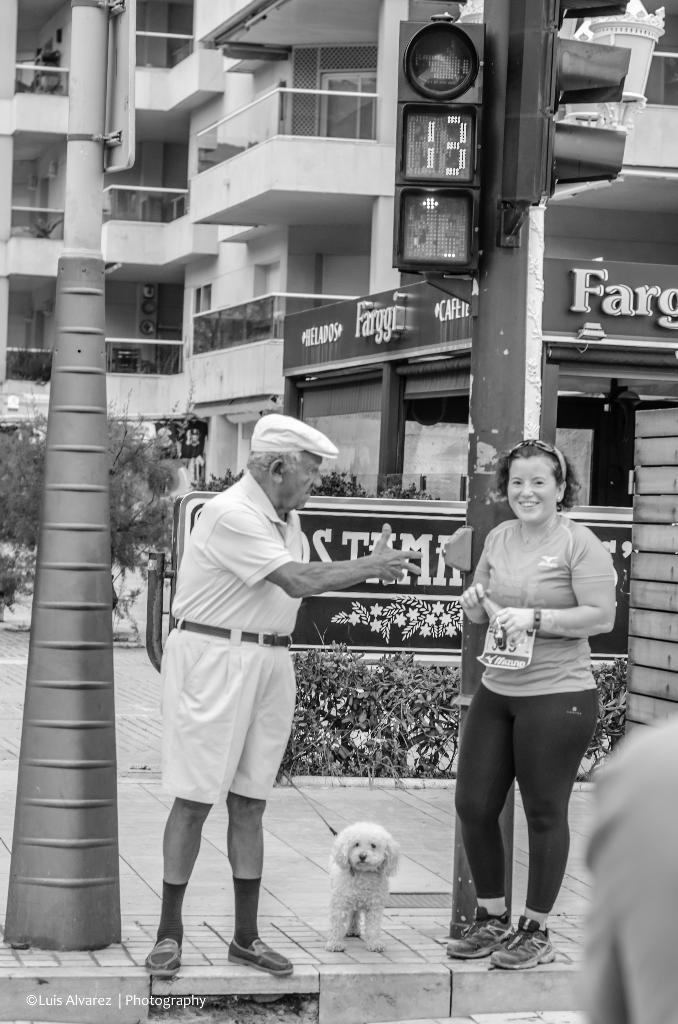How many people are in the image? There is a man and a woman in the image. What is the relationship between the man and woman in the image? The man and woman are standing together. What animal is present in the image? There is a dog in the image. Where is the dog positioned in relation to the man and woman? The dog is between the man and woman. What can be seen in the background of the image? There is a traffic signal, a building, and plants in the background of the image. What type of volleyball game is being played in the image? There is no volleyball game present in the image. Who is the representative of the group in the image? There is no representative mentioned or depicted in the image. 